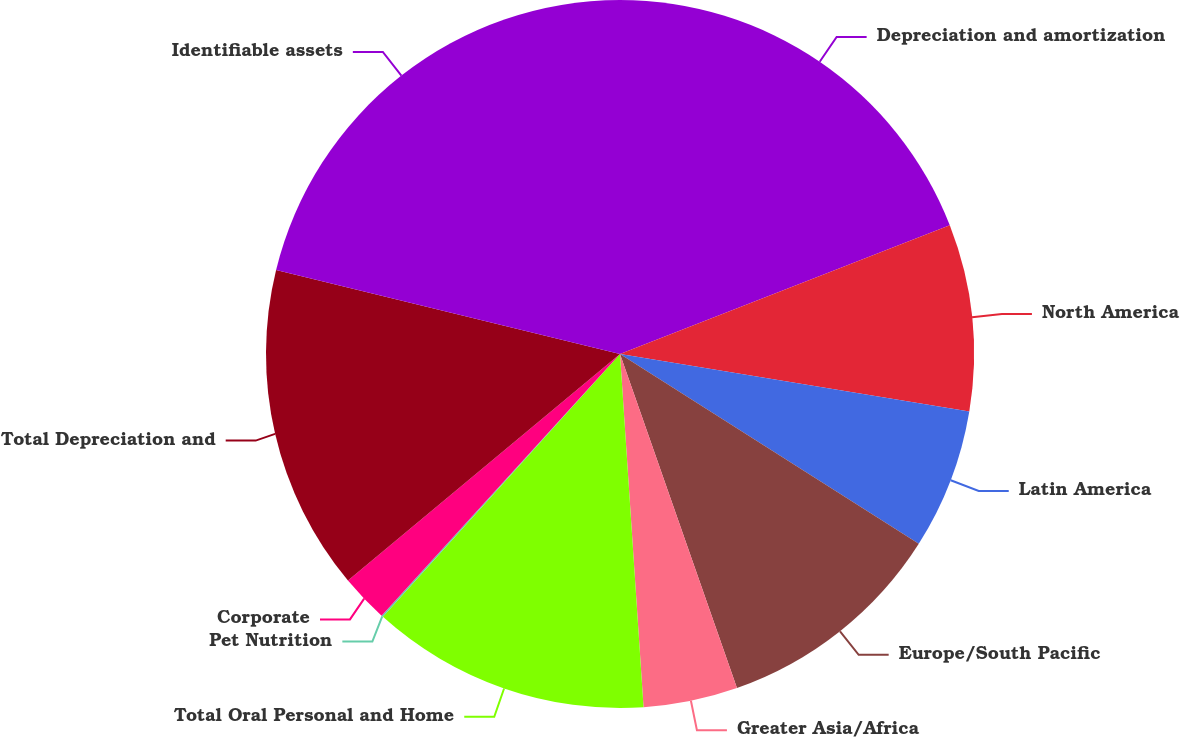Convert chart to OTSL. <chart><loc_0><loc_0><loc_500><loc_500><pie_chart><fcel>Depreciation and amortization<fcel>North America<fcel>Latin America<fcel>Europe/South Pacific<fcel>Greater Asia/Africa<fcel>Total Oral Personal and Home<fcel>Pet Nutrition<fcel>Corporate<fcel>Total Depreciation and<fcel>Identifiable assets<nl><fcel>19.08%<fcel>8.52%<fcel>6.41%<fcel>10.63%<fcel>4.3%<fcel>12.74%<fcel>0.08%<fcel>2.19%<fcel>14.86%<fcel>21.19%<nl></chart> 